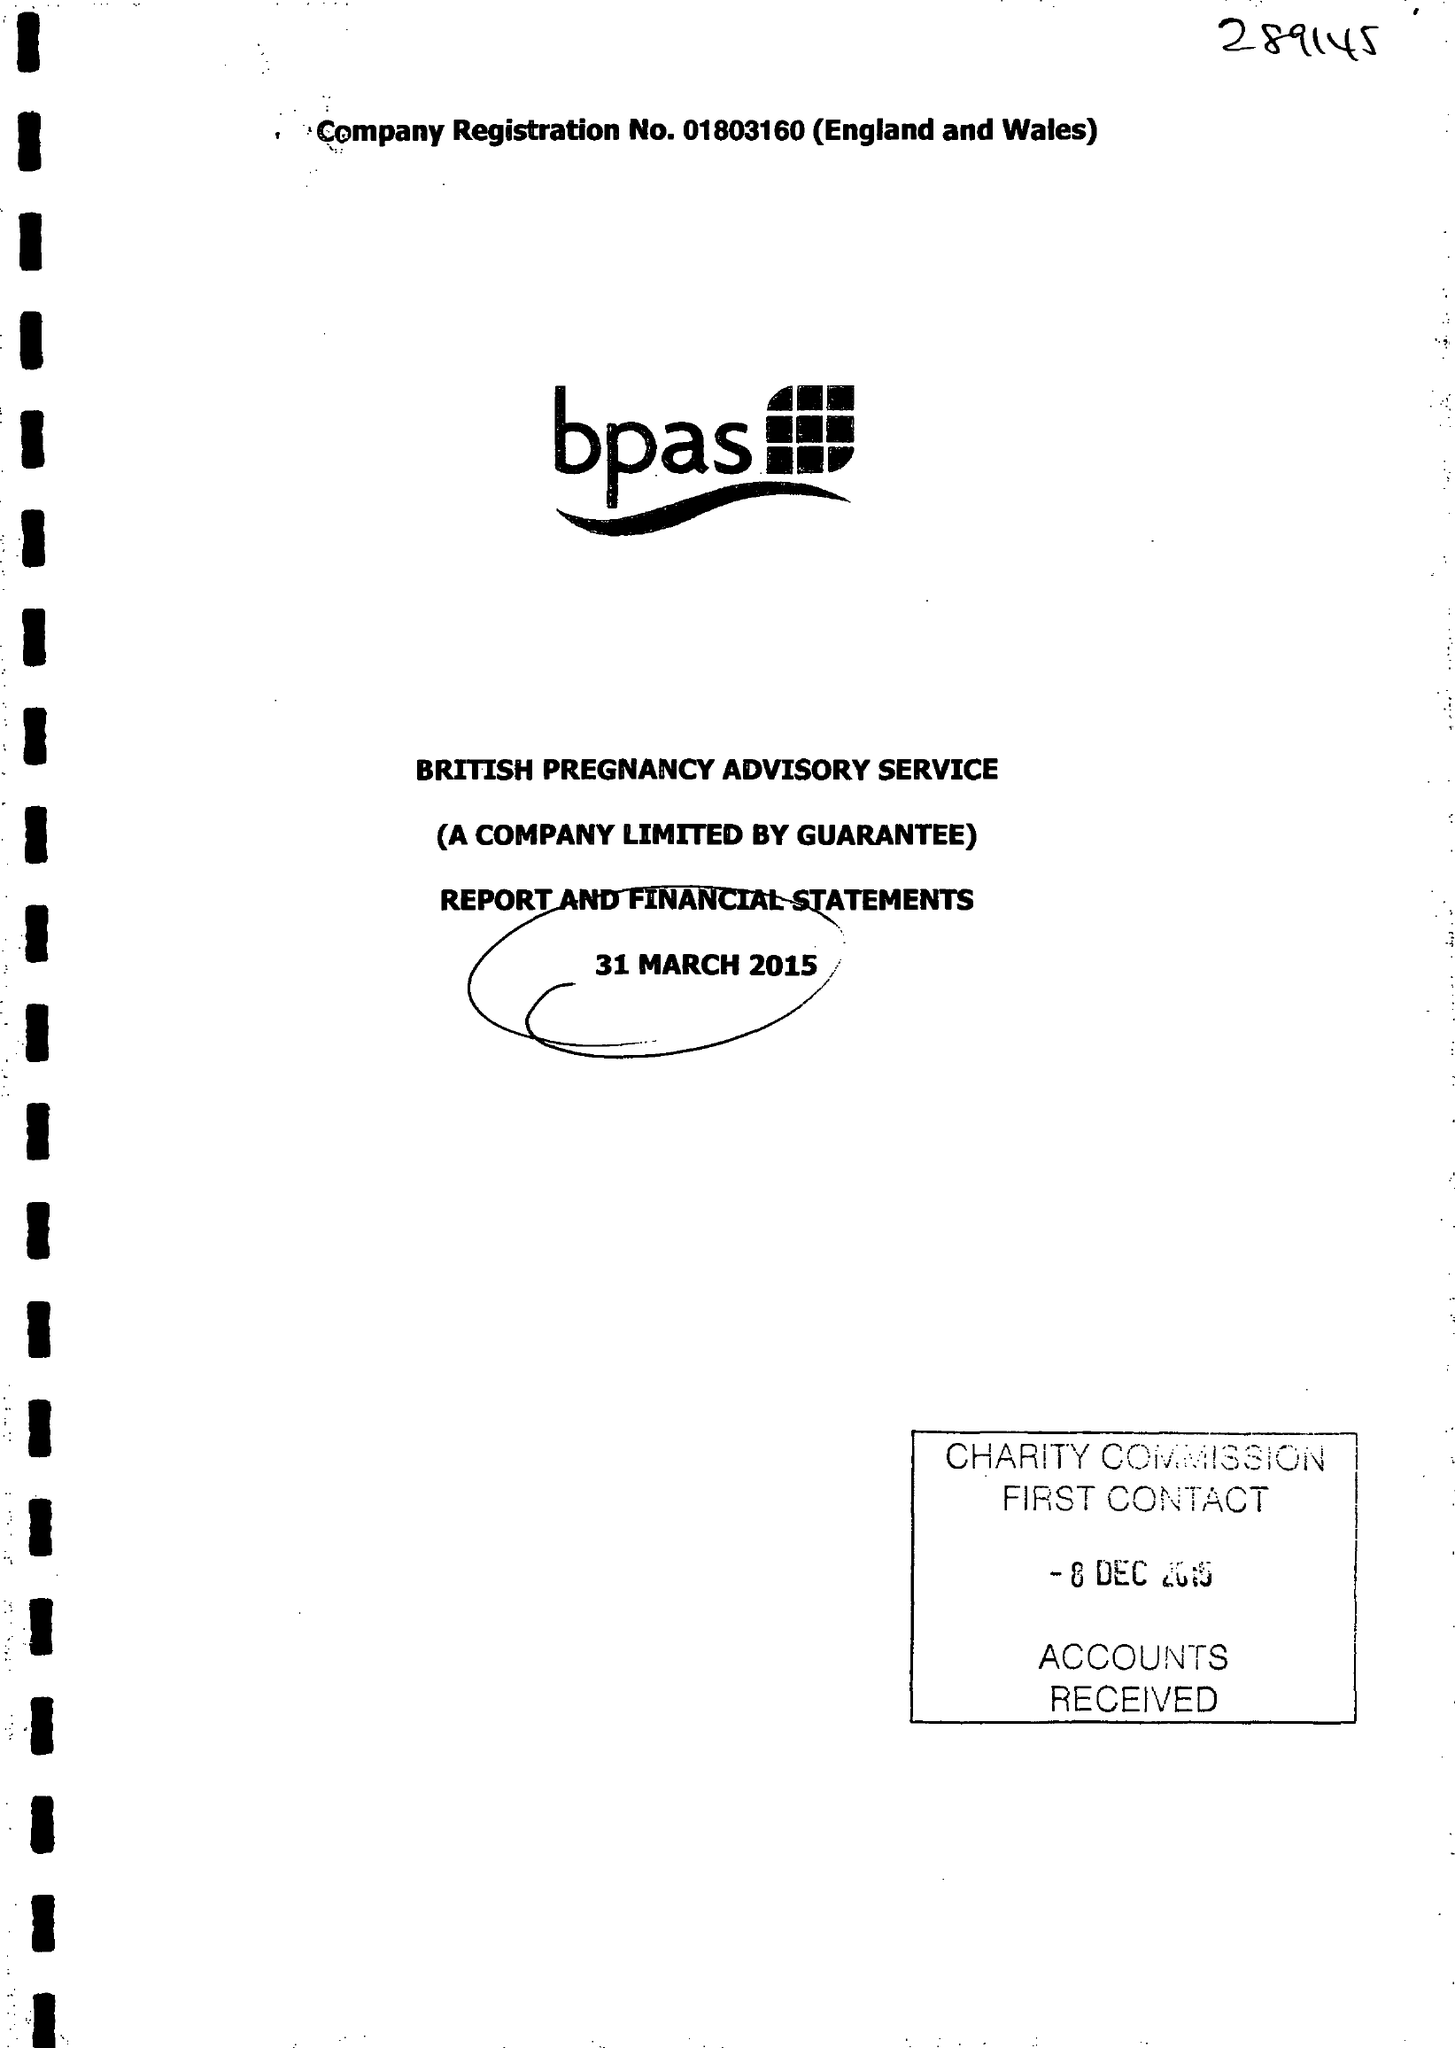What is the value for the income_annually_in_british_pounds?
Answer the question using a single word or phrase. 28440000.00 